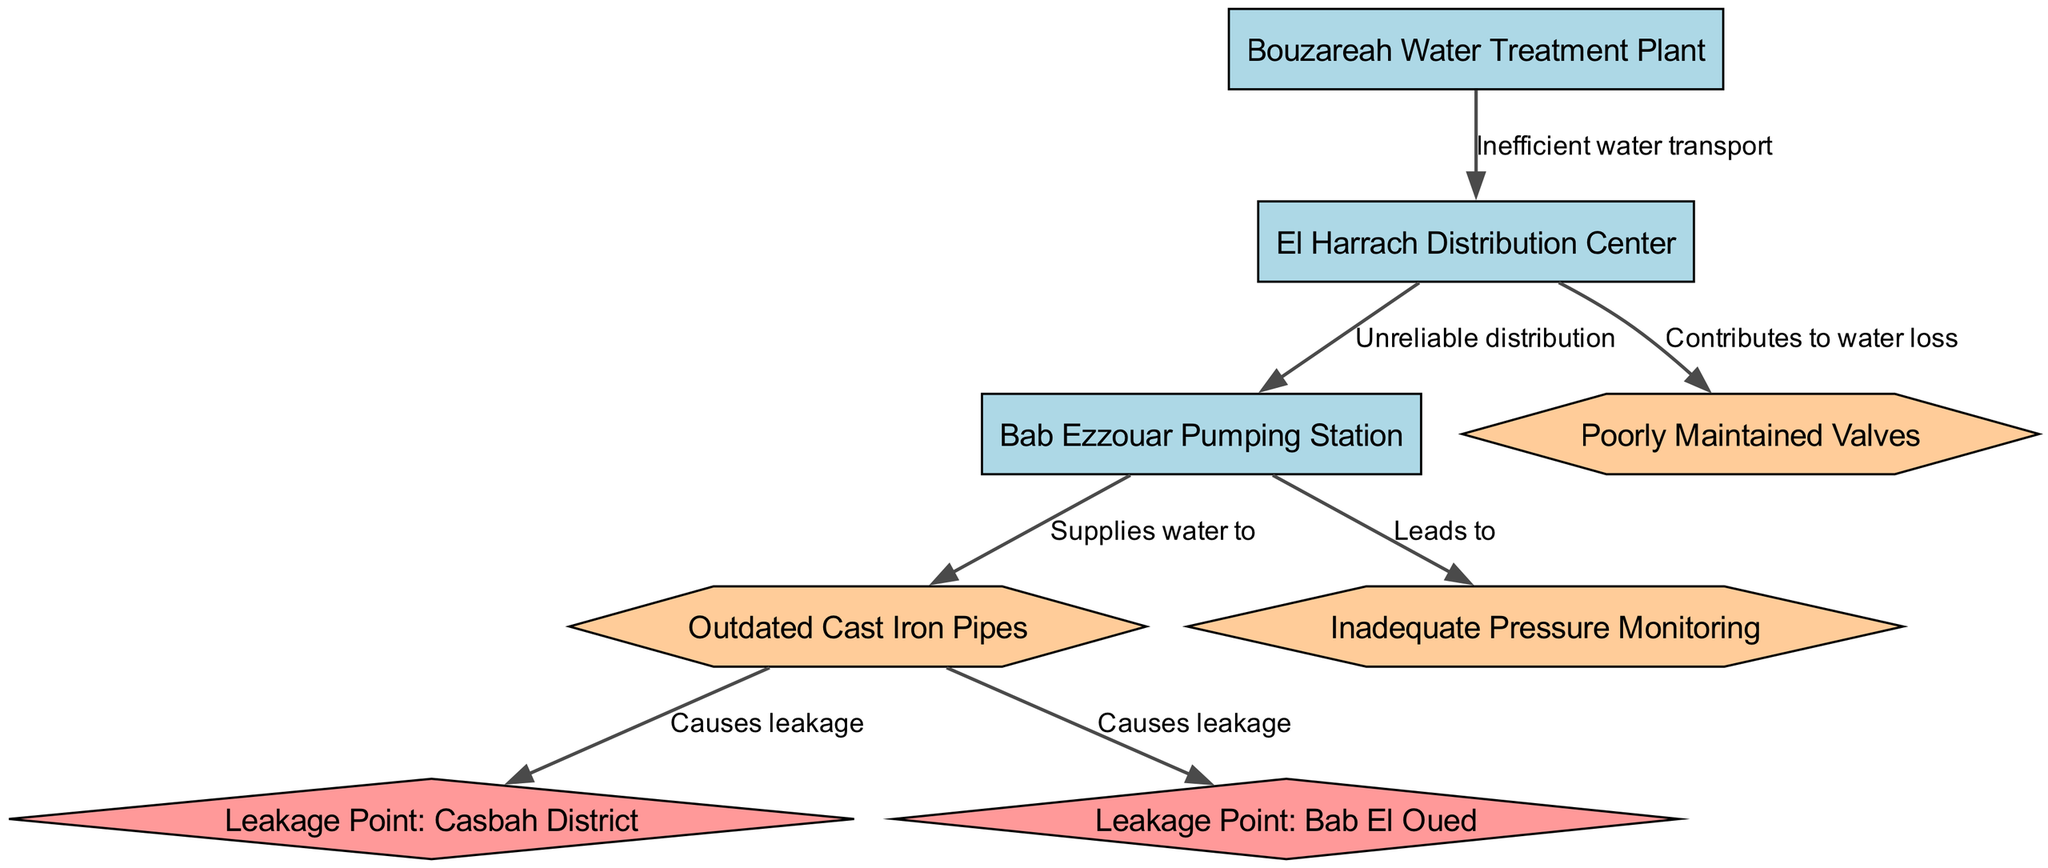What node represents the water treatment facility? The diagram shows "Bouzareah Water Treatment Plant" as the node for the water treatment facility, which is identified as node 1.
Answer: Bouzareah Water Treatment Plant How many leakage points are identified in the diagram? The diagram contains two leakage points: "Leakage Point: Casbah District" and "Leakage Point: Bab El Oued," making a total of two identified leakage points.
Answer: 2 What type of pipes are mentioned in the system? The system references "Outdated Cast Iron Pipes" as the type of pipes, which indicates they are not modern or efficient.
Answer: Outdated Cast Iron Pipes Which node is connected to the "El Harrach Distribution Center" and indicates a problem in the system? The "Poorly Maintained Valves" node is connected to the "El Harrach Distribution Center" and is labeled to contribute to water loss, indicating a problem.
Answer: Poorly Maintained Valves What is the nature of the connection from "Bouzareah Water Treatment Plant" to "El Harrach Distribution Center"? The connection is labeled as "Inefficient water transport," illustrating that the water transport from treatment to distribution is not functioning optimally.
Answer: Inefficient water transport What leads to inadequate pressure monitoring in the system? "Bab Ezzouar Pumping Station" leads to "Inadequate Pressure Monitoring," suggesting a direct link between the pumping station and monitoring issues.
Answer: Inadequate Pressure Monitoring How many total edges are present in the diagram? The diagram shows a total of seven edges connecting different nodes, indicating the relationships and issues within the system.
Answer: 7 Which leakage point is associated with the Casbah District? The leakage point specifically identified is "Leakage Point: Casbah District," which indicates a specific area of concern for water loss.
Answer: Leakage Point: Casbah District What contributes to water loss in the distribution center? The "Poorly Maintained Valves" node contributes to water loss, as it is connected to the "El Harrach Distribution Center" indicating issues in the distribution system.
Answer: Poorly Maintained Valves 